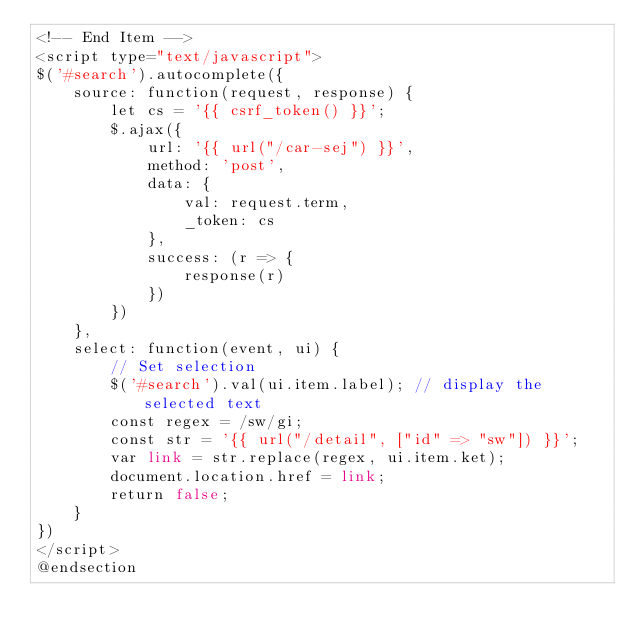Convert code to text. <code><loc_0><loc_0><loc_500><loc_500><_PHP_><!-- End Item -->
<script type="text/javascript">
$('#search').autocomplete({
    source: function(request, response) {
        let cs = '{{ csrf_token() }}';
        $.ajax({
            url: '{{ url("/car-sej") }}',
            method: 'post',
            data: {
                val: request.term,
                _token: cs
            },
            success: (r => {
                response(r)
            })
        })
    },
    select: function(event, ui) {
        // Set selection
        $('#search').val(ui.item.label); // display the selected text
        const regex = /sw/gi;
        const str = '{{ url("/detail", ["id" => "sw"]) }}';
        var link = str.replace(regex, ui.item.ket);
        document.location.href = link;
        return false;
    }
})
</script>
@endsection</code> 